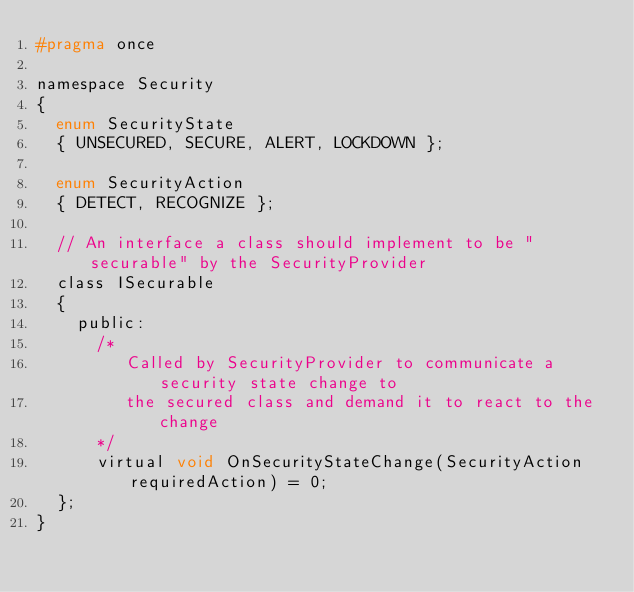Convert code to text. <code><loc_0><loc_0><loc_500><loc_500><_C_>#pragma once

namespace Security
{
	enum SecurityState
	{ UNSECURED, SECURE, ALERT, LOCKDOWN };

	enum SecurityAction
	{ DETECT, RECOGNIZE };

	// An interface a class should implement to be "securable" by the SecurityProvider
	class ISecurable
	{
		public:
			/* 
			   Called by SecurityProvider to communicate a security state change to
			   the secured class and demand it to react to the change
			*/
			virtual void OnSecurityStateChange(SecurityAction requiredAction) = 0;
	};
}</code> 